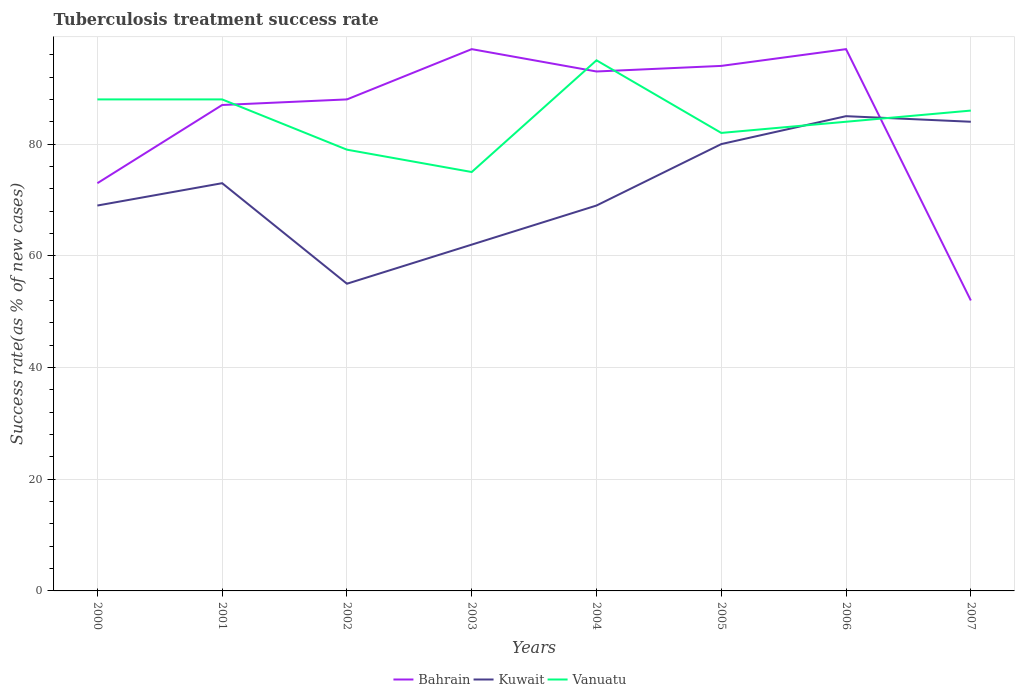How many different coloured lines are there?
Ensure brevity in your answer.  3. Does the line corresponding to Vanuatu intersect with the line corresponding to Kuwait?
Make the answer very short. Yes. What is the difference between the highest and the second highest tuberculosis treatment success rate in Vanuatu?
Your response must be concise. 20. What is the difference between the highest and the lowest tuberculosis treatment success rate in Vanuatu?
Offer a terse response. 4. What is the difference between two consecutive major ticks on the Y-axis?
Offer a very short reply. 20. Are the values on the major ticks of Y-axis written in scientific E-notation?
Your answer should be very brief. No. Does the graph contain grids?
Your answer should be compact. Yes. How many legend labels are there?
Provide a short and direct response. 3. How are the legend labels stacked?
Offer a very short reply. Horizontal. What is the title of the graph?
Keep it short and to the point. Tuberculosis treatment success rate. What is the label or title of the X-axis?
Ensure brevity in your answer.  Years. What is the label or title of the Y-axis?
Provide a short and direct response. Success rate(as % of new cases). What is the Success rate(as % of new cases) of Bahrain in 2000?
Offer a very short reply. 73. What is the Success rate(as % of new cases) in Kuwait in 2000?
Keep it short and to the point. 69. What is the Success rate(as % of new cases) of Vanuatu in 2000?
Offer a very short reply. 88. What is the Success rate(as % of new cases) of Bahrain in 2001?
Ensure brevity in your answer.  87. What is the Success rate(as % of new cases) of Kuwait in 2001?
Ensure brevity in your answer.  73. What is the Success rate(as % of new cases) of Vanuatu in 2001?
Give a very brief answer. 88. What is the Success rate(as % of new cases) of Bahrain in 2002?
Offer a terse response. 88. What is the Success rate(as % of new cases) in Kuwait in 2002?
Your response must be concise. 55. What is the Success rate(as % of new cases) of Vanuatu in 2002?
Ensure brevity in your answer.  79. What is the Success rate(as % of new cases) of Bahrain in 2003?
Offer a very short reply. 97. What is the Success rate(as % of new cases) of Kuwait in 2003?
Provide a succinct answer. 62. What is the Success rate(as % of new cases) in Bahrain in 2004?
Offer a very short reply. 93. What is the Success rate(as % of new cases) of Vanuatu in 2004?
Offer a very short reply. 95. What is the Success rate(as % of new cases) in Bahrain in 2005?
Your answer should be compact. 94. What is the Success rate(as % of new cases) in Kuwait in 2005?
Your response must be concise. 80. What is the Success rate(as % of new cases) in Bahrain in 2006?
Your answer should be compact. 97. What is the Success rate(as % of new cases) in Kuwait in 2006?
Give a very brief answer. 85. What is the Success rate(as % of new cases) of Bahrain in 2007?
Your answer should be compact. 52. What is the Success rate(as % of new cases) of Vanuatu in 2007?
Make the answer very short. 86. Across all years, what is the maximum Success rate(as % of new cases) of Bahrain?
Provide a succinct answer. 97. Across all years, what is the maximum Success rate(as % of new cases) in Vanuatu?
Your response must be concise. 95. Across all years, what is the minimum Success rate(as % of new cases) in Bahrain?
Ensure brevity in your answer.  52. Across all years, what is the minimum Success rate(as % of new cases) in Kuwait?
Your answer should be compact. 55. Across all years, what is the minimum Success rate(as % of new cases) in Vanuatu?
Give a very brief answer. 75. What is the total Success rate(as % of new cases) of Bahrain in the graph?
Provide a short and direct response. 681. What is the total Success rate(as % of new cases) in Kuwait in the graph?
Your response must be concise. 577. What is the total Success rate(as % of new cases) in Vanuatu in the graph?
Offer a very short reply. 677. What is the difference between the Success rate(as % of new cases) of Vanuatu in 2000 and that in 2002?
Your answer should be very brief. 9. What is the difference between the Success rate(as % of new cases) of Bahrain in 2000 and that in 2003?
Your answer should be compact. -24. What is the difference between the Success rate(as % of new cases) of Vanuatu in 2000 and that in 2004?
Give a very brief answer. -7. What is the difference between the Success rate(as % of new cases) in Bahrain in 2000 and that in 2005?
Ensure brevity in your answer.  -21. What is the difference between the Success rate(as % of new cases) in Kuwait in 2000 and that in 2005?
Provide a short and direct response. -11. What is the difference between the Success rate(as % of new cases) of Vanuatu in 2000 and that in 2005?
Provide a succinct answer. 6. What is the difference between the Success rate(as % of new cases) of Vanuatu in 2000 and that in 2006?
Your response must be concise. 4. What is the difference between the Success rate(as % of new cases) of Vanuatu in 2000 and that in 2007?
Offer a very short reply. 2. What is the difference between the Success rate(as % of new cases) of Bahrain in 2001 and that in 2002?
Your answer should be compact. -1. What is the difference between the Success rate(as % of new cases) of Kuwait in 2001 and that in 2002?
Provide a succinct answer. 18. What is the difference between the Success rate(as % of new cases) of Bahrain in 2001 and that in 2003?
Your answer should be very brief. -10. What is the difference between the Success rate(as % of new cases) of Bahrain in 2001 and that in 2004?
Your answer should be very brief. -6. What is the difference between the Success rate(as % of new cases) in Kuwait in 2001 and that in 2004?
Ensure brevity in your answer.  4. What is the difference between the Success rate(as % of new cases) in Vanuatu in 2001 and that in 2004?
Make the answer very short. -7. What is the difference between the Success rate(as % of new cases) of Kuwait in 2001 and that in 2005?
Your answer should be very brief. -7. What is the difference between the Success rate(as % of new cases) in Vanuatu in 2001 and that in 2005?
Provide a short and direct response. 6. What is the difference between the Success rate(as % of new cases) in Kuwait in 2001 and that in 2006?
Make the answer very short. -12. What is the difference between the Success rate(as % of new cases) of Vanuatu in 2001 and that in 2006?
Provide a short and direct response. 4. What is the difference between the Success rate(as % of new cases) of Vanuatu in 2001 and that in 2007?
Give a very brief answer. 2. What is the difference between the Success rate(as % of new cases) of Bahrain in 2002 and that in 2003?
Provide a succinct answer. -9. What is the difference between the Success rate(as % of new cases) of Bahrain in 2002 and that in 2004?
Provide a short and direct response. -5. What is the difference between the Success rate(as % of new cases) of Kuwait in 2002 and that in 2004?
Keep it short and to the point. -14. What is the difference between the Success rate(as % of new cases) of Bahrain in 2002 and that in 2005?
Offer a very short reply. -6. What is the difference between the Success rate(as % of new cases) in Kuwait in 2002 and that in 2006?
Offer a very short reply. -30. What is the difference between the Success rate(as % of new cases) of Vanuatu in 2002 and that in 2006?
Offer a very short reply. -5. What is the difference between the Success rate(as % of new cases) of Kuwait in 2002 and that in 2007?
Provide a short and direct response. -29. What is the difference between the Success rate(as % of new cases) in Vanuatu in 2002 and that in 2007?
Provide a succinct answer. -7. What is the difference between the Success rate(as % of new cases) of Bahrain in 2003 and that in 2004?
Your answer should be compact. 4. What is the difference between the Success rate(as % of new cases) in Kuwait in 2003 and that in 2004?
Your answer should be compact. -7. What is the difference between the Success rate(as % of new cases) in Bahrain in 2003 and that in 2005?
Provide a succinct answer. 3. What is the difference between the Success rate(as % of new cases) of Kuwait in 2003 and that in 2005?
Offer a terse response. -18. What is the difference between the Success rate(as % of new cases) in Bahrain in 2003 and that in 2006?
Your answer should be compact. 0. What is the difference between the Success rate(as % of new cases) in Kuwait in 2003 and that in 2006?
Provide a succinct answer. -23. What is the difference between the Success rate(as % of new cases) of Vanuatu in 2003 and that in 2006?
Offer a terse response. -9. What is the difference between the Success rate(as % of new cases) in Kuwait in 2003 and that in 2007?
Make the answer very short. -22. What is the difference between the Success rate(as % of new cases) of Bahrain in 2004 and that in 2005?
Provide a short and direct response. -1. What is the difference between the Success rate(as % of new cases) of Kuwait in 2004 and that in 2005?
Your answer should be very brief. -11. What is the difference between the Success rate(as % of new cases) of Vanuatu in 2004 and that in 2005?
Provide a succinct answer. 13. What is the difference between the Success rate(as % of new cases) of Bahrain in 2004 and that in 2006?
Your response must be concise. -4. What is the difference between the Success rate(as % of new cases) of Kuwait in 2004 and that in 2006?
Your response must be concise. -16. What is the difference between the Success rate(as % of new cases) in Vanuatu in 2004 and that in 2006?
Keep it short and to the point. 11. What is the difference between the Success rate(as % of new cases) in Bahrain in 2004 and that in 2007?
Give a very brief answer. 41. What is the difference between the Success rate(as % of new cases) of Bahrain in 2005 and that in 2007?
Keep it short and to the point. 42. What is the difference between the Success rate(as % of new cases) of Vanuatu in 2005 and that in 2007?
Keep it short and to the point. -4. What is the difference between the Success rate(as % of new cases) of Bahrain in 2006 and that in 2007?
Your answer should be very brief. 45. What is the difference between the Success rate(as % of new cases) of Vanuatu in 2006 and that in 2007?
Your answer should be very brief. -2. What is the difference between the Success rate(as % of new cases) in Bahrain in 2000 and the Success rate(as % of new cases) in Kuwait in 2001?
Make the answer very short. 0. What is the difference between the Success rate(as % of new cases) in Bahrain in 2000 and the Success rate(as % of new cases) in Kuwait in 2002?
Keep it short and to the point. 18. What is the difference between the Success rate(as % of new cases) in Bahrain in 2000 and the Success rate(as % of new cases) in Vanuatu in 2002?
Offer a very short reply. -6. What is the difference between the Success rate(as % of new cases) in Kuwait in 2000 and the Success rate(as % of new cases) in Vanuatu in 2002?
Provide a succinct answer. -10. What is the difference between the Success rate(as % of new cases) in Bahrain in 2000 and the Success rate(as % of new cases) in Vanuatu in 2003?
Offer a terse response. -2. What is the difference between the Success rate(as % of new cases) of Kuwait in 2000 and the Success rate(as % of new cases) of Vanuatu in 2003?
Ensure brevity in your answer.  -6. What is the difference between the Success rate(as % of new cases) of Bahrain in 2000 and the Success rate(as % of new cases) of Vanuatu in 2004?
Ensure brevity in your answer.  -22. What is the difference between the Success rate(as % of new cases) of Kuwait in 2000 and the Success rate(as % of new cases) of Vanuatu in 2004?
Your answer should be very brief. -26. What is the difference between the Success rate(as % of new cases) of Bahrain in 2000 and the Success rate(as % of new cases) of Kuwait in 2005?
Keep it short and to the point. -7. What is the difference between the Success rate(as % of new cases) in Bahrain in 2000 and the Success rate(as % of new cases) in Vanuatu in 2005?
Your answer should be compact. -9. What is the difference between the Success rate(as % of new cases) of Kuwait in 2000 and the Success rate(as % of new cases) of Vanuatu in 2005?
Provide a succinct answer. -13. What is the difference between the Success rate(as % of new cases) of Bahrain in 2000 and the Success rate(as % of new cases) of Kuwait in 2006?
Your response must be concise. -12. What is the difference between the Success rate(as % of new cases) of Bahrain in 2000 and the Success rate(as % of new cases) of Vanuatu in 2006?
Offer a terse response. -11. What is the difference between the Success rate(as % of new cases) in Kuwait in 2000 and the Success rate(as % of new cases) in Vanuatu in 2006?
Your answer should be compact. -15. What is the difference between the Success rate(as % of new cases) in Bahrain in 2000 and the Success rate(as % of new cases) in Vanuatu in 2007?
Your answer should be compact. -13. What is the difference between the Success rate(as % of new cases) in Bahrain in 2001 and the Success rate(as % of new cases) in Kuwait in 2002?
Provide a short and direct response. 32. What is the difference between the Success rate(as % of new cases) of Kuwait in 2001 and the Success rate(as % of new cases) of Vanuatu in 2002?
Give a very brief answer. -6. What is the difference between the Success rate(as % of new cases) in Bahrain in 2001 and the Success rate(as % of new cases) in Kuwait in 2003?
Your answer should be compact. 25. What is the difference between the Success rate(as % of new cases) in Bahrain in 2001 and the Success rate(as % of new cases) in Vanuatu in 2003?
Provide a short and direct response. 12. What is the difference between the Success rate(as % of new cases) of Kuwait in 2001 and the Success rate(as % of new cases) of Vanuatu in 2003?
Keep it short and to the point. -2. What is the difference between the Success rate(as % of new cases) in Kuwait in 2001 and the Success rate(as % of new cases) in Vanuatu in 2004?
Keep it short and to the point. -22. What is the difference between the Success rate(as % of new cases) of Bahrain in 2001 and the Success rate(as % of new cases) of Vanuatu in 2005?
Ensure brevity in your answer.  5. What is the difference between the Success rate(as % of new cases) of Kuwait in 2001 and the Success rate(as % of new cases) of Vanuatu in 2005?
Offer a very short reply. -9. What is the difference between the Success rate(as % of new cases) in Bahrain in 2001 and the Success rate(as % of new cases) in Kuwait in 2006?
Make the answer very short. 2. What is the difference between the Success rate(as % of new cases) in Bahrain in 2001 and the Success rate(as % of new cases) in Vanuatu in 2007?
Provide a short and direct response. 1. What is the difference between the Success rate(as % of new cases) in Bahrain in 2002 and the Success rate(as % of new cases) in Vanuatu in 2004?
Provide a succinct answer. -7. What is the difference between the Success rate(as % of new cases) in Kuwait in 2002 and the Success rate(as % of new cases) in Vanuatu in 2004?
Provide a succinct answer. -40. What is the difference between the Success rate(as % of new cases) of Bahrain in 2002 and the Success rate(as % of new cases) of Vanuatu in 2005?
Make the answer very short. 6. What is the difference between the Success rate(as % of new cases) of Kuwait in 2002 and the Success rate(as % of new cases) of Vanuatu in 2005?
Provide a short and direct response. -27. What is the difference between the Success rate(as % of new cases) in Bahrain in 2002 and the Success rate(as % of new cases) in Kuwait in 2006?
Your answer should be very brief. 3. What is the difference between the Success rate(as % of new cases) of Bahrain in 2002 and the Success rate(as % of new cases) of Vanuatu in 2006?
Provide a short and direct response. 4. What is the difference between the Success rate(as % of new cases) in Kuwait in 2002 and the Success rate(as % of new cases) in Vanuatu in 2006?
Your response must be concise. -29. What is the difference between the Success rate(as % of new cases) of Bahrain in 2002 and the Success rate(as % of new cases) of Kuwait in 2007?
Ensure brevity in your answer.  4. What is the difference between the Success rate(as % of new cases) in Bahrain in 2002 and the Success rate(as % of new cases) in Vanuatu in 2007?
Offer a terse response. 2. What is the difference between the Success rate(as % of new cases) of Kuwait in 2002 and the Success rate(as % of new cases) of Vanuatu in 2007?
Give a very brief answer. -31. What is the difference between the Success rate(as % of new cases) in Kuwait in 2003 and the Success rate(as % of new cases) in Vanuatu in 2004?
Your answer should be very brief. -33. What is the difference between the Success rate(as % of new cases) in Bahrain in 2003 and the Success rate(as % of new cases) in Kuwait in 2005?
Your answer should be very brief. 17. What is the difference between the Success rate(as % of new cases) in Kuwait in 2003 and the Success rate(as % of new cases) in Vanuatu in 2005?
Give a very brief answer. -20. What is the difference between the Success rate(as % of new cases) in Bahrain in 2003 and the Success rate(as % of new cases) in Vanuatu in 2006?
Your answer should be compact. 13. What is the difference between the Success rate(as % of new cases) of Kuwait in 2003 and the Success rate(as % of new cases) of Vanuatu in 2006?
Your answer should be compact. -22. What is the difference between the Success rate(as % of new cases) in Bahrain in 2003 and the Success rate(as % of new cases) in Vanuatu in 2007?
Your answer should be compact. 11. What is the difference between the Success rate(as % of new cases) in Bahrain in 2004 and the Success rate(as % of new cases) in Vanuatu in 2005?
Ensure brevity in your answer.  11. What is the difference between the Success rate(as % of new cases) of Kuwait in 2004 and the Success rate(as % of new cases) of Vanuatu in 2005?
Make the answer very short. -13. What is the difference between the Success rate(as % of new cases) of Bahrain in 2004 and the Success rate(as % of new cases) of Kuwait in 2006?
Provide a short and direct response. 8. What is the difference between the Success rate(as % of new cases) in Bahrain in 2004 and the Success rate(as % of new cases) in Vanuatu in 2006?
Make the answer very short. 9. What is the difference between the Success rate(as % of new cases) of Bahrain in 2004 and the Success rate(as % of new cases) of Kuwait in 2007?
Your answer should be very brief. 9. What is the difference between the Success rate(as % of new cases) of Bahrain in 2004 and the Success rate(as % of new cases) of Vanuatu in 2007?
Offer a terse response. 7. What is the difference between the Success rate(as % of new cases) of Kuwait in 2004 and the Success rate(as % of new cases) of Vanuatu in 2007?
Your answer should be very brief. -17. What is the difference between the Success rate(as % of new cases) of Bahrain in 2005 and the Success rate(as % of new cases) of Kuwait in 2006?
Give a very brief answer. 9. What is the difference between the Success rate(as % of new cases) of Bahrain in 2005 and the Success rate(as % of new cases) of Vanuatu in 2006?
Keep it short and to the point. 10. What is the difference between the Success rate(as % of new cases) in Kuwait in 2005 and the Success rate(as % of new cases) in Vanuatu in 2006?
Offer a terse response. -4. What is the difference between the Success rate(as % of new cases) in Kuwait in 2005 and the Success rate(as % of new cases) in Vanuatu in 2007?
Keep it short and to the point. -6. What is the difference between the Success rate(as % of new cases) of Bahrain in 2006 and the Success rate(as % of new cases) of Vanuatu in 2007?
Give a very brief answer. 11. What is the average Success rate(as % of new cases) of Bahrain per year?
Offer a terse response. 85.12. What is the average Success rate(as % of new cases) in Kuwait per year?
Ensure brevity in your answer.  72.12. What is the average Success rate(as % of new cases) of Vanuatu per year?
Keep it short and to the point. 84.62. In the year 2000, what is the difference between the Success rate(as % of new cases) in Bahrain and Success rate(as % of new cases) in Vanuatu?
Ensure brevity in your answer.  -15. In the year 2000, what is the difference between the Success rate(as % of new cases) in Kuwait and Success rate(as % of new cases) in Vanuatu?
Your response must be concise. -19. In the year 2001, what is the difference between the Success rate(as % of new cases) of Bahrain and Success rate(as % of new cases) of Vanuatu?
Your answer should be very brief. -1. In the year 2001, what is the difference between the Success rate(as % of new cases) of Kuwait and Success rate(as % of new cases) of Vanuatu?
Ensure brevity in your answer.  -15. In the year 2002, what is the difference between the Success rate(as % of new cases) of Bahrain and Success rate(as % of new cases) of Vanuatu?
Ensure brevity in your answer.  9. In the year 2002, what is the difference between the Success rate(as % of new cases) of Kuwait and Success rate(as % of new cases) of Vanuatu?
Offer a terse response. -24. In the year 2003, what is the difference between the Success rate(as % of new cases) in Bahrain and Success rate(as % of new cases) in Kuwait?
Give a very brief answer. 35. In the year 2003, what is the difference between the Success rate(as % of new cases) of Bahrain and Success rate(as % of new cases) of Vanuatu?
Make the answer very short. 22. In the year 2003, what is the difference between the Success rate(as % of new cases) in Kuwait and Success rate(as % of new cases) in Vanuatu?
Keep it short and to the point. -13. In the year 2004, what is the difference between the Success rate(as % of new cases) of Bahrain and Success rate(as % of new cases) of Kuwait?
Provide a short and direct response. 24. In the year 2004, what is the difference between the Success rate(as % of new cases) of Kuwait and Success rate(as % of new cases) of Vanuatu?
Give a very brief answer. -26. In the year 2006, what is the difference between the Success rate(as % of new cases) of Bahrain and Success rate(as % of new cases) of Kuwait?
Provide a short and direct response. 12. In the year 2006, what is the difference between the Success rate(as % of new cases) in Bahrain and Success rate(as % of new cases) in Vanuatu?
Keep it short and to the point. 13. In the year 2006, what is the difference between the Success rate(as % of new cases) of Kuwait and Success rate(as % of new cases) of Vanuatu?
Your answer should be very brief. 1. In the year 2007, what is the difference between the Success rate(as % of new cases) of Bahrain and Success rate(as % of new cases) of Kuwait?
Provide a short and direct response. -32. In the year 2007, what is the difference between the Success rate(as % of new cases) of Bahrain and Success rate(as % of new cases) of Vanuatu?
Provide a succinct answer. -34. In the year 2007, what is the difference between the Success rate(as % of new cases) in Kuwait and Success rate(as % of new cases) in Vanuatu?
Offer a very short reply. -2. What is the ratio of the Success rate(as % of new cases) in Bahrain in 2000 to that in 2001?
Ensure brevity in your answer.  0.84. What is the ratio of the Success rate(as % of new cases) of Kuwait in 2000 to that in 2001?
Your answer should be compact. 0.95. What is the ratio of the Success rate(as % of new cases) of Bahrain in 2000 to that in 2002?
Keep it short and to the point. 0.83. What is the ratio of the Success rate(as % of new cases) of Kuwait in 2000 to that in 2002?
Ensure brevity in your answer.  1.25. What is the ratio of the Success rate(as % of new cases) in Vanuatu in 2000 to that in 2002?
Provide a succinct answer. 1.11. What is the ratio of the Success rate(as % of new cases) in Bahrain in 2000 to that in 2003?
Make the answer very short. 0.75. What is the ratio of the Success rate(as % of new cases) in Kuwait in 2000 to that in 2003?
Provide a succinct answer. 1.11. What is the ratio of the Success rate(as % of new cases) in Vanuatu in 2000 to that in 2003?
Ensure brevity in your answer.  1.17. What is the ratio of the Success rate(as % of new cases) in Bahrain in 2000 to that in 2004?
Make the answer very short. 0.78. What is the ratio of the Success rate(as % of new cases) of Kuwait in 2000 to that in 2004?
Offer a terse response. 1. What is the ratio of the Success rate(as % of new cases) in Vanuatu in 2000 to that in 2004?
Your response must be concise. 0.93. What is the ratio of the Success rate(as % of new cases) in Bahrain in 2000 to that in 2005?
Provide a succinct answer. 0.78. What is the ratio of the Success rate(as % of new cases) of Kuwait in 2000 to that in 2005?
Provide a short and direct response. 0.86. What is the ratio of the Success rate(as % of new cases) in Vanuatu in 2000 to that in 2005?
Your answer should be very brief. 1.07. What is the ratio of the Success rate(as % of new cases) in Bahrain in 2000 to that in 2006?
Make the answer very short. 0.75. What is the ratio of the Success rate(as % of new cases) in Kuwait in 2000 to that in 2006?
Provide a short and direct response. 0.81. What is the ratio of the Success rate(as % of new cases) in Vanuatu in 2000 to that in 2006?
Offer a very short reply. 1.05. What is the ratio of the Success rate(as % of new cases) of Bahrain in 2000 to that in 2007?
Your answer should be very brief. 1.4. What is the ratio of the Success rate(as % of new cases) in Kuwait in 2000 to that in 2007?
Keep it short and to the point. 0.82. What is the ratio of the Success rate(as % of new cases) in Vanuatu in 2000 to that in 2007?
Offer a terse response. 1.02. What is the ratio of the Success rate(as % of new cases) in Bahrain in 2001 to that in 2002?
Provide a succinct answer. 0.99. What is the ratio of the Success rate(as % of new cases) of Kuwait in 2001 to that in 2002?
Ensure brevity in your answer.  1.33. What is the ratio of the Success rate(as % of new cases) of Vanuatu in 2001 to that in 2002?
Offer a terse response. 1.11. What is the ratio of the Success rate(as % of new cases) in Bahrain in 2001 to that in 2003?
Ensure brevity in your answer.  0.9. What is the ratio of the Success rate(as % of new cases) of Kuwait in 2001 to that in 2003?
Make the answer very short. 1.18. What is the ratio of the Success rate(as % of new cases) of Vanuatu in 2001 to that in 2003?
Your answer should be very brief. 1.17. What is the ratio of the Success rate(as % of new cases) of Bahrain in 2001 to that in 2004?
Ensure brevity in your answer.  0.94. What is the ratio of the Success rate(as % of new cases) of Kuwait in 2001 to that in 2004?
Give a very brief answer. 1.06. What is the ratio of the Success rate(as % of new cases) of Vanuatu in 2001 to that in 2004?
Your answer should be compact. 0.93. What is the ratio of the Success rate(as % of new cases) in Bahrain in 2001 to that in 2005?
Your answer should be very brief. 0.93. What is the ratio of the Success rate(as % of new cases) of Kuwait in 2001 to that in 2005?
Ensure brevity in your answer.  0.91. What is the ratio of the Success rate(as % of new cases) of Vanuatu in 2001 to that in 2005?
Your response must be concise. 1.07. What is the ratio of the Success rate(as % of new cases) in Bahrain in 2001 to that in 2006?
Provide a short and direct response. 0.9. What is the ratio of the Success rate(as % of new cases) in Kuwait in 2001 to that in 2006?
Provide a succinct answer. 0.86. What is the ratio of the Success rate(as % of new cases) of Vanuatu in 2001 to that in 2006?
Your answer should be compact. 1.05. What is the ratio of the Success rate(as % of new cases) of Bahrain in 2001 to that in 2007?
Offer a terse response. 1.67. What is the ratio of the Success rate(as % of new cases) in Kuwait in 2001 to that in 2007?
Your response must be concise. 0.87. What is the ratio of the Success rate(as % of new cases) of Vanuatu in 2001 to that in 2007?
Provide a succinct answer. 1.02. What is the ratio of the Success rate(as % of new cases) of Bahrain in 2002 to that in 2003?
Provide a short and direct response. 0.91. What is the ratio of the Success rate(as % of new cases) of Kuwait in 2002 to that in 2003?
Your response must be concise. 0.89. What is the ratio of the Success rate(as % of new cases) of Vanuatu in 2002 to that in 2003?
Your response must be concise. 1.05. What is the ratio of the Success rate(as % of new cases) of Bahrain in 2002 to that in 2004?
Give a very brief answer. 0.95. What is the ratio of the Success rate(as % of new cases) of Kuwait in 2002 to that in 2004?
Your answer should be very brief. 0.8. What is the ratio of the Success rate(as % of new cases) of Vanuatu in 2002 to that in 2004?
Keep it short and to the point. 0.83. What is the ratio of the Success rate(as % of new cases) of Bahrain in 2002 to that in 2005?
Offer a terse response. 0.94. What is the ratio of the Success rate(as % of new cases) in Kuwait in 2002 to that in 2005?
Your answer should be very brief. 0.69. What is the ratio of the Success rate(as % of new cases) of Vanuatu in 2002 to that in 2005?
Keep it short and to the point. 0.96. What is the ratio of the Success rate(as % of new cases) of Bahrain in 2002 to that in 2006?
Provide a succinct answer. 0.91. What is the ratio of the Success rate(as % of new cases) of Kuwait in 2002 to that in 2006?
Ensure brevity in your answer.  0.65. What is the ratio of the Success rate(as % of new cases) of Vanuatu in 2002 to that in 2006?
Your answer should be compact. 0.94. What is the ratio of the Success rate(as % of new cases) in Bahrain in 2002 to that in 2007?
Your answer should be very brief. 1.69. What is the ratio of the Success rate(as % of new cases) of Kuwait in 2002 to that in 2007?
Make the answer very short. 0.65. What is the ratio of the Success rate(as % of new cases) in Vanuatu in 2002 to that in 2007?
Your answer should be very brief. 0.92. What is the ratio of the Success rate(as % of new cases) of Bahrain in 2003 to that in 2004?
Keep it short and to the point. 1.04. What is the ratio of the Success rate(as % of new cases) of Kuwait in 2003 to that in 2004?
Your response must be concise. 0.9. What is the ratio of the Success rate(as % of new cases) in Vanuatu in 2003 to that in 2004?
Offer a very short reply. 0.79. What is the ratio of the Success rate(as % of new cases) of Bahrain in 2003 to that in 2005?
Offer a very short reply. 1.03. What is the ratio of the Success rate(as % of new cases) in Kuwait in 2003 to that in 2005?
Your response must be concise. 0.78. What is the ratio of the Success rate(as % of new cases) of Vanuatu in 2003 to that in 2005?
Your answer should be compact. 0.91. What is the ratio of the Success rate(as % of new cases) of Bahrain in 2003 to that in 2006?
Keep it short and to the point. 1. What is the ratio of the Success rate(as % of new cases) in Kuwait in 2003 to that in 2006?
Offer a very short reply. 0.73. What is the ratio of the Success rate(as % of new cases) in Vanuatu in 2003 to that in 2006?
Offer a terse response. 0.89. What is the ratio of the Success rate(as % of new cases) in Bahrain in 2003 to that in 2007?
Your answer should be compact. 1.87. What is the ratio of the Success rate(as % of new cases) in Kuwait in 2003 to that in 2007?
Your answer should be compact. 0.74. What is the ratio of the Success rate(as % of new cases) in Vanuatu in 2003 to that in 2007?
Your answer should be compact. 0.87. What is the ratio of the Success rate(as % of new cases) in Bahrain in 2004 to that in 2005?
Ensure brevity in your answer.  0.99. What is the ratio of the Success rate(as % of new cases) in Kuwait in 2004 to that in 2005?
Offer a very short reply. 0.86. What is the ratio of the Success rate(as % of new cases) in Vanuatu in 2004 to that in 2005?
Make the answer very short. 1.16. What is the ratio of the Success rate(as % of new cases) of Bahrain in 2004 to that in 2006?
Provide a short and direct response. 0.96. What is the ratio of the Success rate(as % of new cases) in Kuwait in 2004 to that in 2006?
Give a very brief answer. 0.81. What is the ratio of the Success rate(as % of new cases) of Vanuatu in 2004 to that in 2006?
Provide a succinct answer. 1.13. What is the ratio of the Success rate(as % of new cases) of Bahrain in 2004 to that in 2007?
Make the answer very short. 1.79. What is the ratio of the Success rate(as % of new cases) in Kuwait in 2004 to that in 2007?
Offer a very short reply. 0.82. What is the ratio of the Success rate(as % of new cases) of Vanuatu in 2004 to that in 2007?
Offer a terse response. 1.1. What is the ratio of the Success rate(as % of new cases) of Bahrain in 2005 to that in 2006?
Provide a succinct answer. 0.97. What is the ratio of the Success rate(as % of new cases) of Vanuatu in 2005 to that in 2006?
Your response must be concise. 0.98. What is the ratio of the Success rate(as % of new cases) of Bahrain in 2005 to that in 2007?
Ensure brevity in your answer.  1.81. What is the ratio of the Success rate(as % of new cases) of Vanuatu in 2005 to that in 2007?
Provide a succinct answer. 0.95. What is the ratio of the Success rate(as % of new cases) in Bahrain in 2006 to that in 2007?
Your response must be concise. 1.87. What is the ratio of the Success rate(as % of new cases) of Kuwait in 2006 to that in 2007?
Offer a terse response. 1.01. What is the ratio of the Success rate(as % of new cases) of Vanuatu in 2006 to that in 2007?
Keep it short and to the point. 0.98. What is the difference between the highest and the lowest Success rate(as % of new cases) in Bahrain?
Give a very brief answer. 45. What is the difference between the highest and the lowest Success rate(as % of new cases) of Vanuatu?
Make the answer very short. 20. 